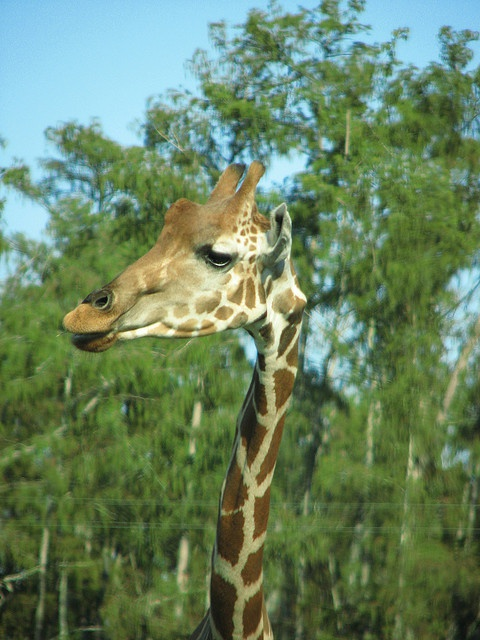Describe the objects in this image and their specific colors. I can see a giraffe in lightblue, tan, olive, khaki, and black tones in this image. 